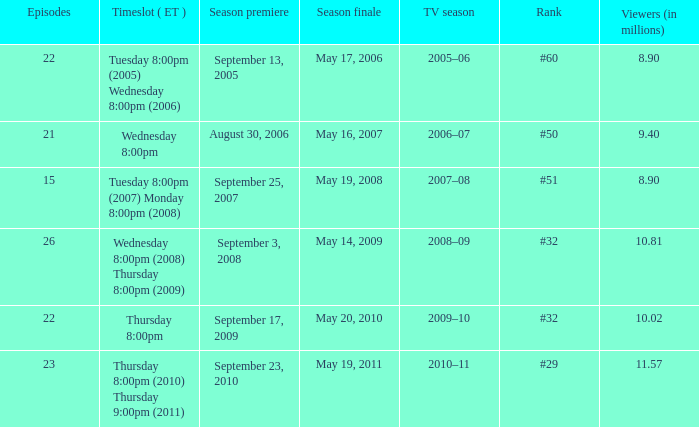How many seasons was the rank equal to #50? 1.0. 